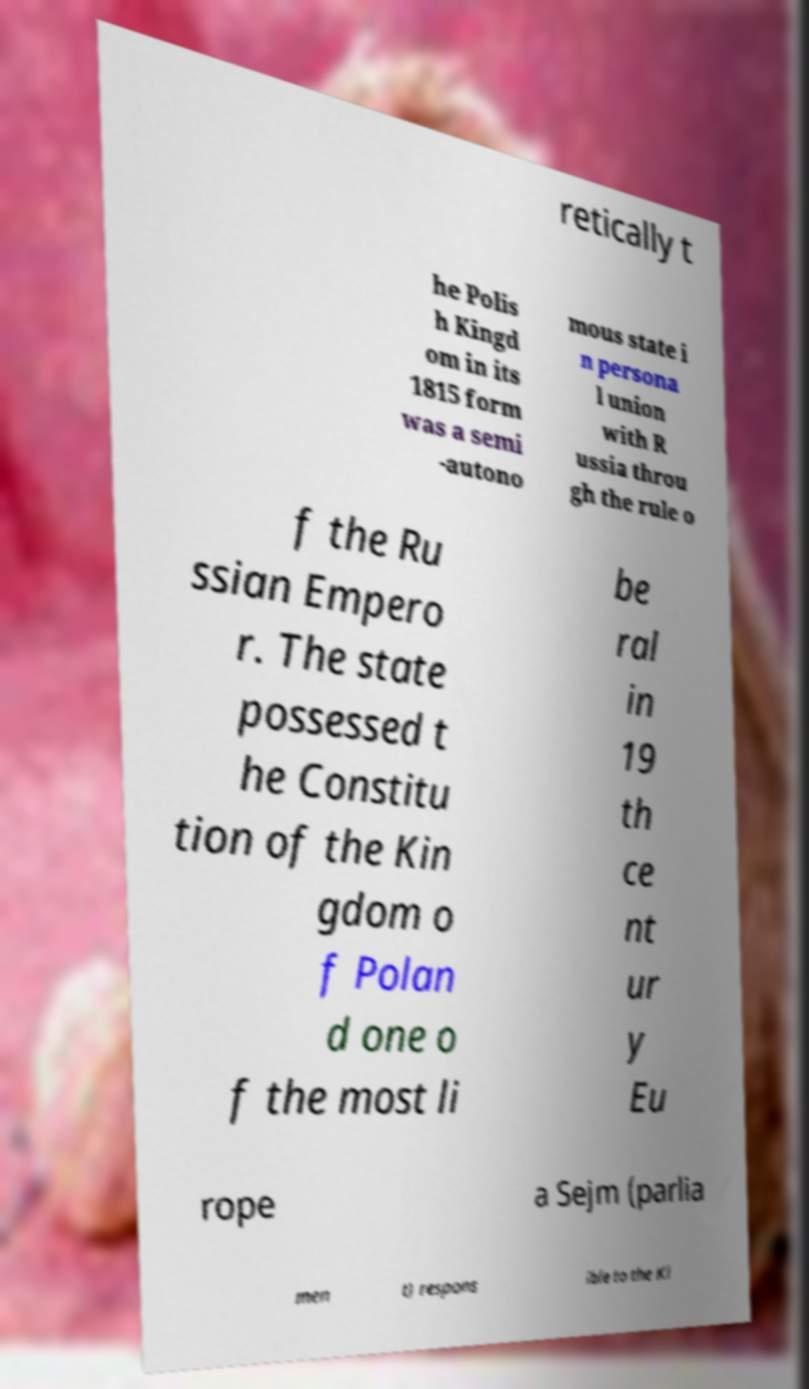What messages or text are displayed in this image? I need them in a readable, typed format. retically t he Polis h Kingd om in its 1815 form was a semi -autono mous state i n persona l union with R ussia throu gh the rule o f the Ru ssian Empero r. The state possessed t he Constitu tion of the Kin gdom o f Polan d one o f the most li be ral in 19 th ce nt ur y Eu rope a Sejm (parlia men t) respons ible to the Ki 